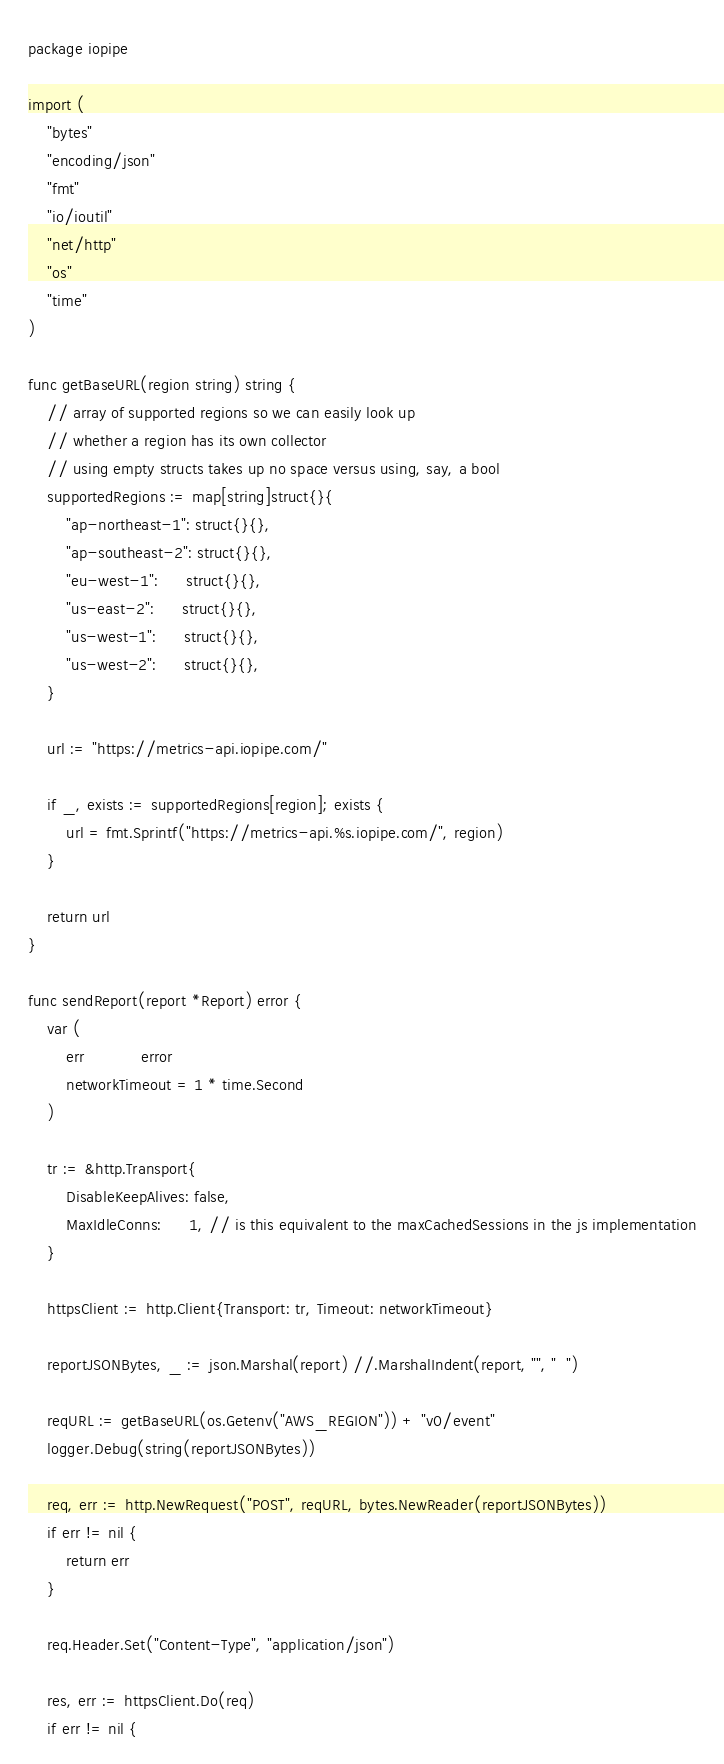Convert code to text. <code><loc_0><loc_0><loc_500><loc_500><_Go_>package iopipe

import (
	"bytes"
	"encoding/json"
	"fmt"
	"io/ioutil"
	"net/http"
	"os"
	"time"
)

func getBaseURL(region string) string {
	// array of supported regions so we can easily look up
	// whether a region has its own collector
	// using empty structs takes up no space versus using, say, a bool
	supportedRegions := map[string]struct{}{
		"ap-northeast-1": struct{}{},
		"ap-southeast-2": struct{}{},
		"eu-west-1":      struct{}{},
		"us-east-2":      struct{}{},
		"us-west-1":      struct{}{},
		"us-west-2":      struct{}{},
	}

	url := "https://metrics-api.iopipe.com/"

	if _, exists := supportedRegions[region]; exists {
		url = fmt.Sprintf("https://metrics-api.%s.iopipe.com/", region)
	}

	return url
}

func sendReport(report *Report) error {
	var (
		err            error
		networkTimeout = 1 * time.Second
	)

	tr := &http.Transport{
		DisableKeepAlives: false,
		MaxIdleConns:      1, // is this equivalent to the maxCachedSessions in the js implementation
	}

	httpsClient := http.Client{Transport: tr, Timeout: networkTimeout}

	reportJSONBytes, _ := json.Marshal(report) //.MarshalIndent(report, "", "  ")

	reqURL := getBaseURL(os.Getenv("AWS_REGION")) + "v0/event"
	logger.Debug(string(reportJSONBytes))

	req, err := http.NewRequest("POST", reqURL, bytes.NewReader(reportJSONBytes))
	if err != nil {
		return err
	}

	req.Header.Set("Content-Type", "application/json")

	res, err := httpsClient.Do(req)
	if err != nil {</code> 